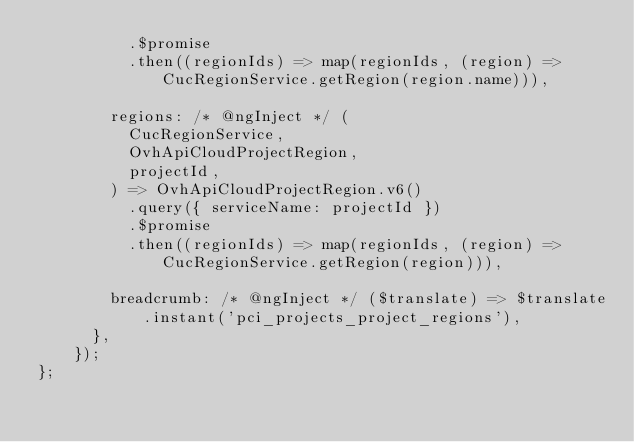<code> <loc_0><loc_0><loc_500><loc_500><_JavaScript_>          .$promise
          .then((regionIds) => map(regionIds, (region) => CucRegionService.getRegion(region.name))),

        regions: /* @ngInject */ (
          CucRegionService,
          OvhApiCloudProjectRegion,
          projectId,
        ) => OvhApiCloudProjectRegion.v6()
          .query({ serviceName: projectId })
          .$promise
          .then((regionIds) => map(regionIds, (region) => CucRegionService.getRegion(region))),

        breadcrumb: /* @ngInject */ ($translate) => $translate.instant('pci_projects_project_regions'),
      },
    });
};
</code> 